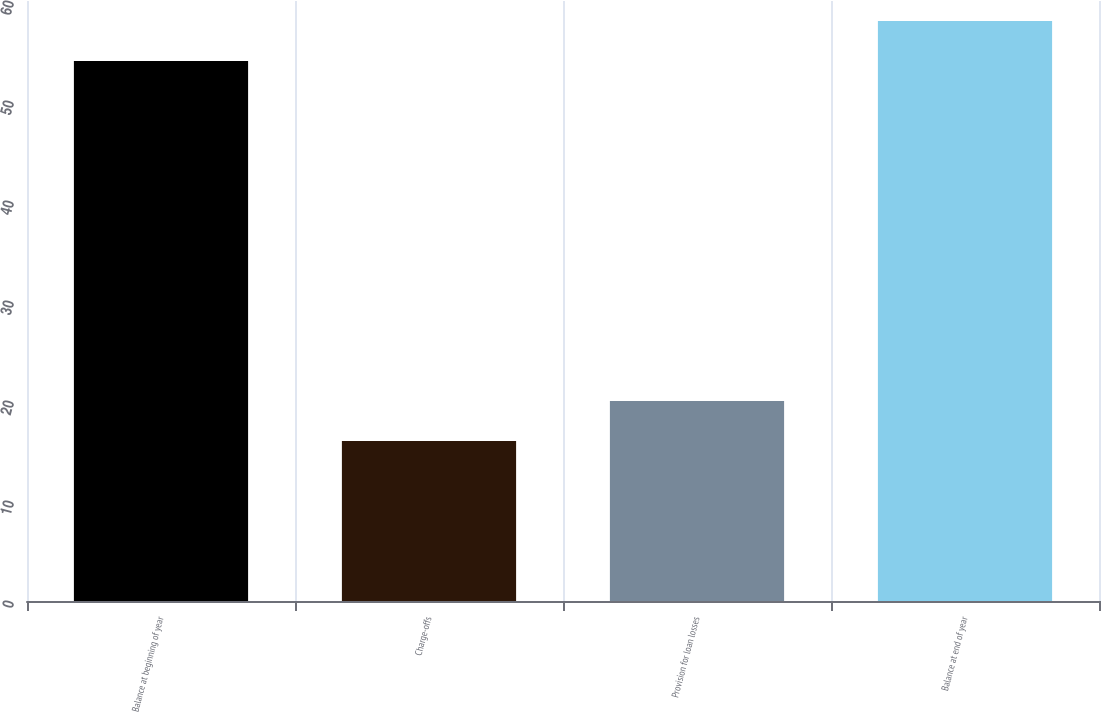<chart> <loc_0><loc_0><loc_500><loc_500><bar_chart><fcel>Balance at beginning of year<fcel>Charge-offs<fcel>Provision for loan losses<fcel>Balance at end of year<nl><fcel>54<fcel>16<fcel>20<fcel>58<nl></chart> 